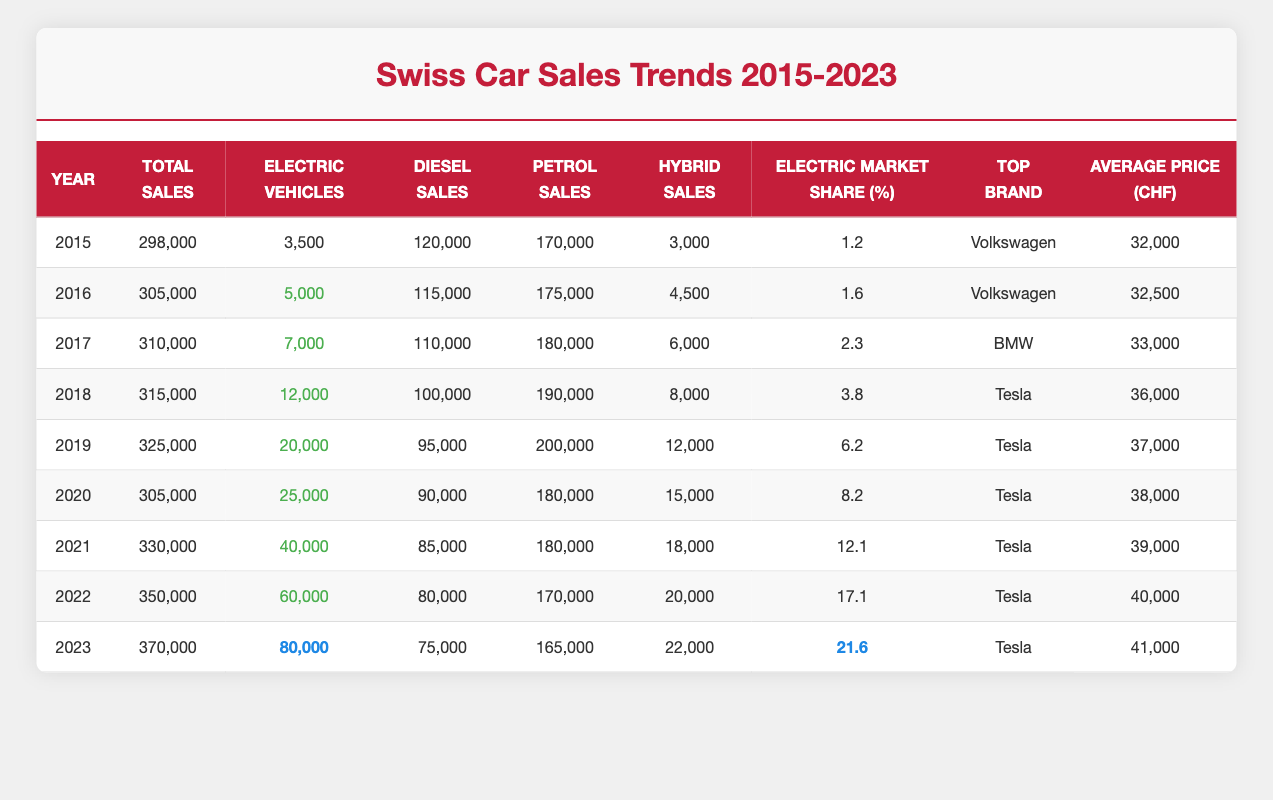What was the total car sales in Switzerland in 2020? The table shows total sales for each year. For 2020, the total sales are listed as 305,000.
Answer: 305,000 Which year had the highest sales of electric vehicles? By checking the electric vehicle sales column, the year 2023 shows the highest with 80,000 electric vehicles sold.
Answer: 2023 What is the average price of cars sold in Switzerland in 2021? The average price for 2021 is provided in the table, which is listed as 39,000 CHF.
Answer: 39,000 CHF Did the market share percentage for electric vehicles increase every year from 2015 to 2023? By examining the market share column, it is clear that the values increase each year from 1.2% in 2015 to 21.6% in 2023, confirming an increase every year.
Answer: Yes How many more petrol cars were sold in 2019 compared to 2015? The petrol sales figures for 2019 is 200,000 and for 2015 is 170,000. The difference is 200,000 - 170,000 = 30,000, which indicates the increase in sales.
Answer: 30,000 In which year was the top-selling brand Volkswagen replaced by another brand? Volkswagen was the top brand for 2015 and 2016; it was replaced by BMW in 2017, as seen in the table.
Answer: 2017 What is the percentage increase in average car price from 2015 to 2023? The average price increased from 32,000 in 2015 to 41,000 in 2023. The percentage increase is calculated as (41,000 - 32,000) / 32,000 * 100% = 28.125%.
Answer: 28.125% How many diesel cars were sold in 2022? The table specifies diesel sales for 2022 as 80,000.
Answer: 80,000 What was the total number of hybrid cars sold in the years 2018 and 2021 combined? The figures for hybrid sales are 8,000 in 2018 and 18,000 in 2021. Combining these gives a total of 8,000 + 18,000 = 26,000 hybrid cars sold.
Answer: 26,000 